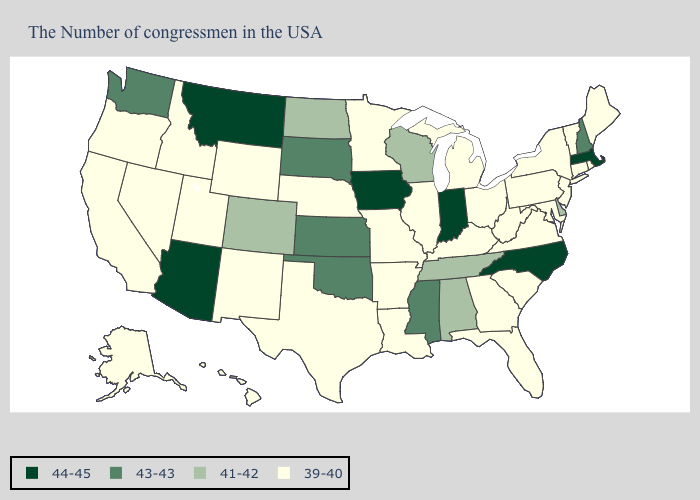Name the states that have a value in the range 44-45?
Quick response, please. Massachusetts, North Carolina, Indiana, Iowa, Montana, Arizona. What is the lowest value in the West?
Write a very short answer. 39-40. Does the first symbol in the legend represent the smallest category?
Keep it brief. No. Does California have a lower value than Arizona?
Concise answer only. Yes. Name the states that have a value in the range 41-42?
Concise answer only. Delaware, Alabama, Tennessee, Wisconsin, North Dakota, Colorado. What is the highest value in states that border Texas?
Write a very short answer. 43-43. Which states hav the highest value in the West?
Write a very short answer. Montana, Arizona. Name the states that have a value in the range 43-43?
Quick response, please. New Hampshire, Mississippi, Kansas, Oklahoma, South Dakota, Washington. What is the value of North Carolina?
Answer briefly. 44-45. What is the value of Utah?
Short answer required. 39-40. Which states have the lowest value in the USA?
Short answer required. Maine, Rhode Island, Vermont, Connecticut, New York, New Jersey, Maryland, Pennsylvania, Virginia, South Carolina, West Virginia, Ohio, Florida, Georgia, Michigan, Kentucky, Illinois, Louisiana, Missouri, Arkansas, Minnesota, Nebraska, Texas, Wyoming, New Mexico, Utah, Idaho, Nevada, California, Oregon, Alaska, Hawaii. What is the highest value in states that border South Carolina?
Be succinct. 44-45. Does North Carolina have the lowest value in the USA?
Be succinct. No. Among the states that border New Jersey , which have the highest value?
Write a very short answer. Delaware. Does Oregon have the highest value in the USA?
Write a very short answer. No. 